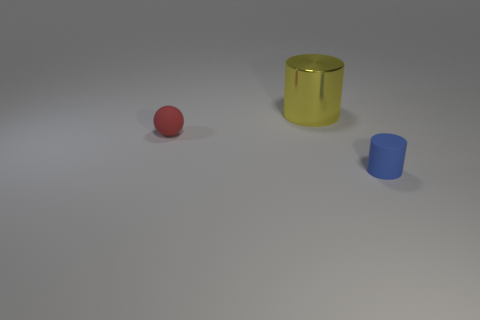Does the object to the left of the big cylinder have the same material as the cylinder left of the blue object?
Keep it short and to the point. No. Does the tiny rubber object to the left of the big shiny thing have the same color as the matte cylinder?
Offer a very short reply. No. What number of cylinders are behind the large cylinder?
Keep it short and to the point. 0. Is the sphere made of the same material as the cylinder to the right of the yellow thing?
Your answer should be compact. Yes. The thing that is the same material as the red ball is what size?
Keep it short and to the point. Small. Is the number of tiny balls that are behind the shiny cylinder greater than the number of blue objects to the left of the rubber ball?
Keep it short and to the point. No. Are there any cyan objects of the same shape as the big yellow object?
Offer a terse response. No. Is the size of the cylinder behind the red matte ball the same as the small blue object?
Your answer should be compact. No. Are there any large brown matte cylinders?
Your answer should be compact. No. What number of objects are small matte things left of the yellow metal cylinder or tiny brown matte objects?
Your answer should be very brief. 1. 